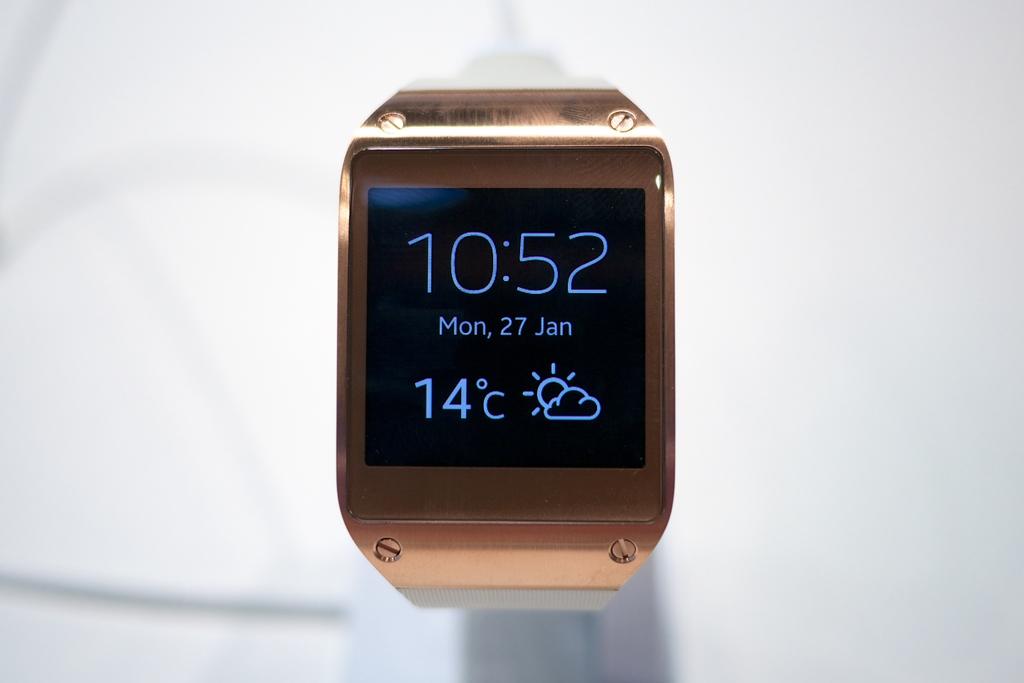What is the temperature shown?
Make the answer very short. 14 c. What time is shown on the watch?
Your answer should be very brief. 10:52. 